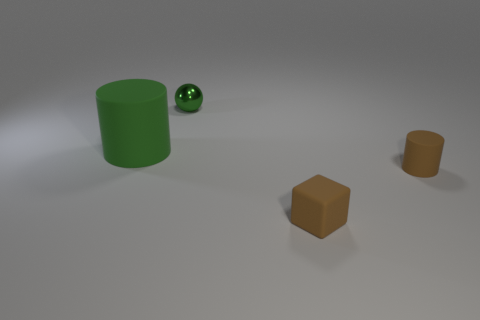Add 2 tiny things. How many objects exist? 6 Subtract all green cylinders. How many cylinders are left? 1 Subtract all brown cylinders. Subtract all green cylinders. How many objects are left? 2 Add 2 brown cylinders. How many brown cylinders are left? 3 Add 3 balls. How many balls exist? 4 Subtract 1 brown cubes. How many objects are left? 3 Subtract all spheres. How many objects are left? 3 Subtract all blue cylinders. Subtract all brown cubes. How many cylinders are left? 2 Subtract all yellow cubes. How many brown cylinders are left? 1 